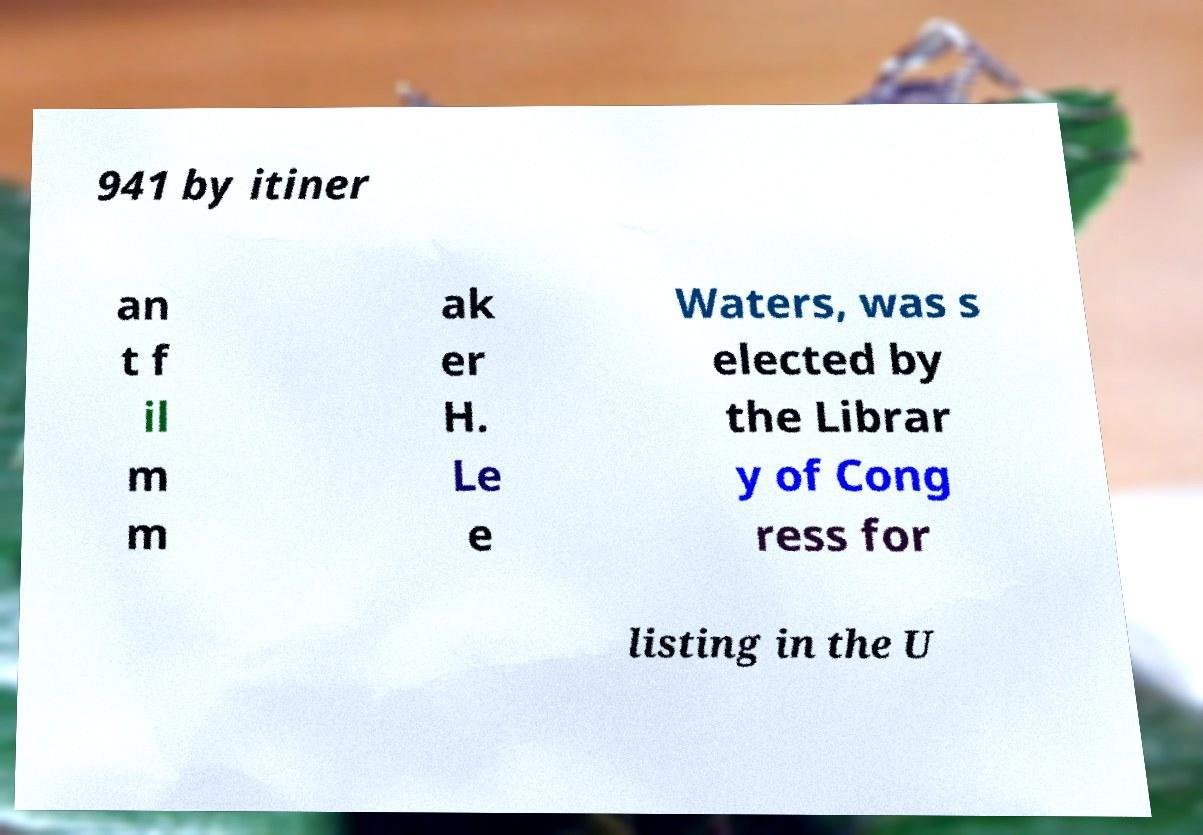Please identify and transcribe the text found in this image. 941 by itiner an t f il m m ak er H. Le e Waters, was s elected by the Librar y of Cong ress for listing in the U 